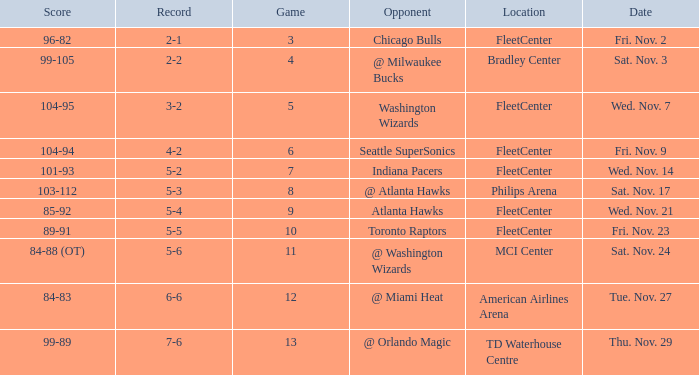How many games have a score of 85-92? 1.0. 